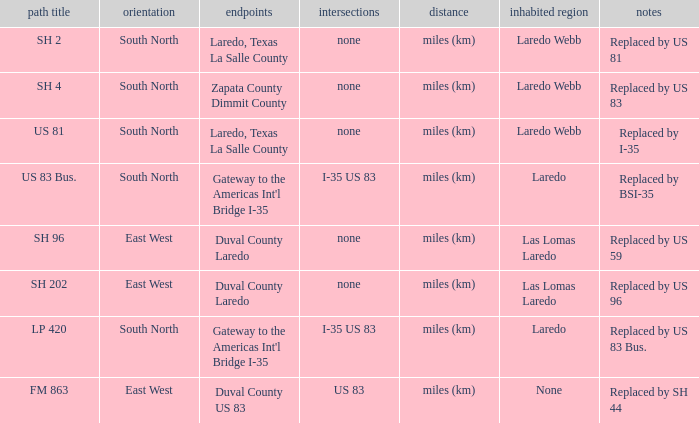Which junctions have "replaced by bsi-35" listed in their remarks section? I-35 US 83. 